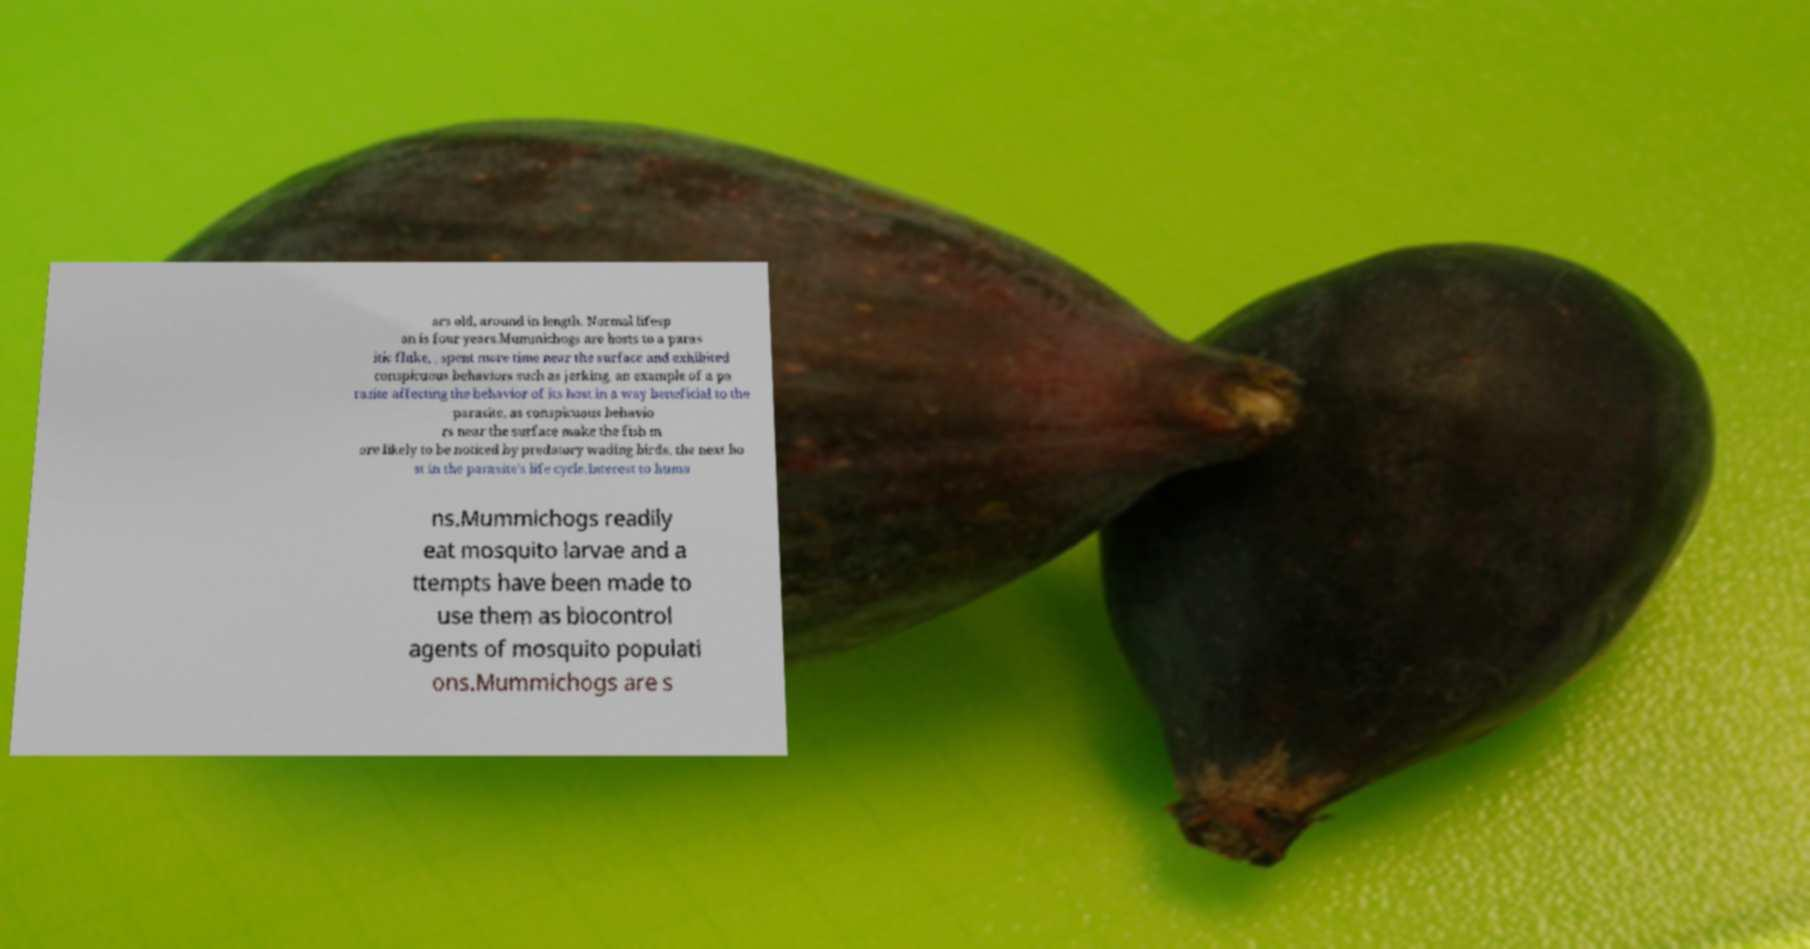I need the written content from this picture converted into text. Can you do that? ars old, around in length. Normal lifesp an is four years.Mummichogs are hosts to a paras itic fluke, , spent more time near the surface and exhibited conspicuous behaviors such as jerking, an example of a pa rasite affecting the behavior of its host in a way beneficial to the parasite, as conspicuous behavio rs near the surface make the fish m ore likely to be noticed by predatory wading birds, the next ho st in the parasite's life cycle.Interest to huma ns.Mummichogs readily eat mosquito larvae and a ttempts have been made to use them as biocontrol agents of mosquito populati ons.Mummichogs are s 